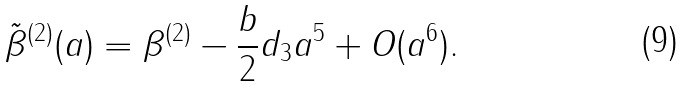Convert formula to latex. <formula><loc_0><loc_0><loc_500><loc_500>\tilde { \beta } ^ { ( 2 ) } ( a ) = \beta ^ { ( 2 ) } - \frac { b } { 2 } d _ { 3 } a ^ { 5 } + O ( a ^ { 6 } ) .</formula> 